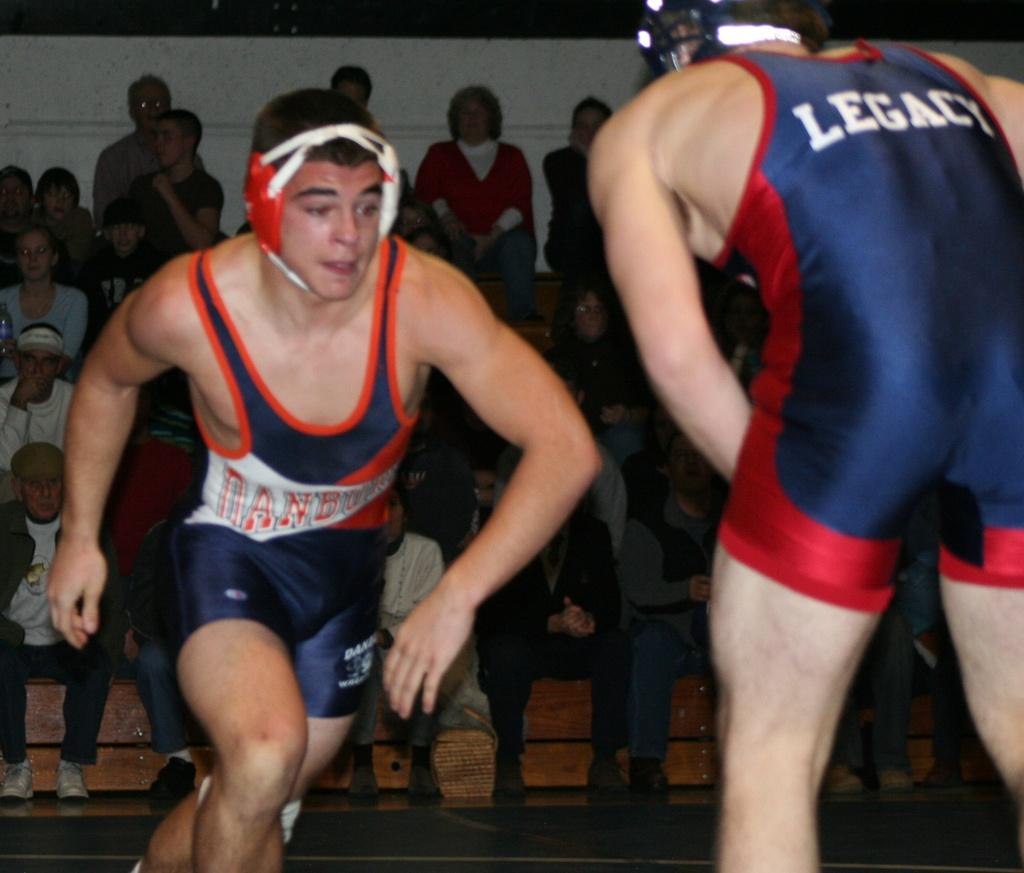Provide a one-sentence caption for the provided image. Blue suit with Legacy wrote on the back. 